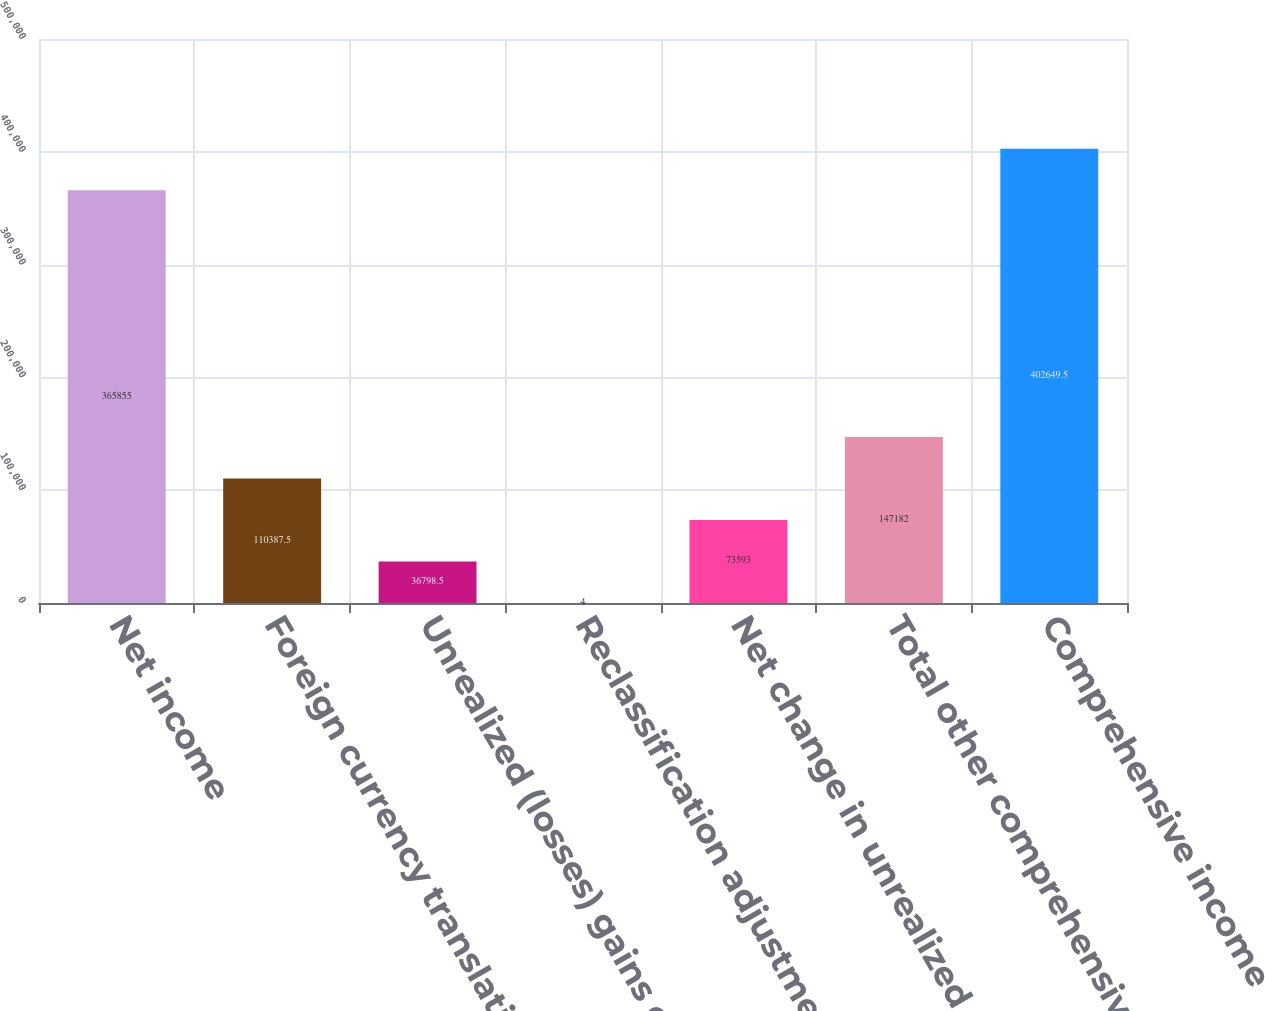Convert chart to OTSL. <chart><loc_0><loc_0><loc_500><loc_500><bar_chart><fcel>Net income<fcel>Foreign currency translation<fcel>Unrealized (losses) gains on<fcel>Reclassification adjustment<fcel>Net change in unrealized<fcel>Total other comprehensive<fcel>Comprehensive income<nl><fcel>365855<fcel>110388<fcel>36798.5<fcel>4<fcel>73593<fcel>147182<fcel>402650<nl></chart> 